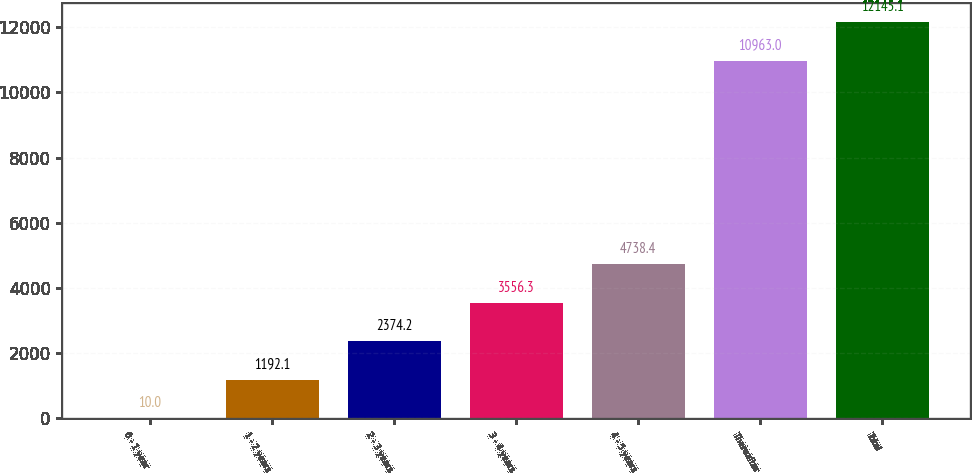Convert chart. <chart><loc_0><loc_0><loc_500><loc_500><bar_chart><fcel>0 - 1 year<fcel>1 - 2 years<fcel>2 - 3 years<fcel>3 - 4 years<fcel>4 - 5 years<fcel>Thereafter<fcel>Total<nl><fcel>10<fcel>1192.1<fcel>2374.2<fcel>3556.3<fcel>4738.4<fcel>10963<fcel>12145.1<nl></chart> 